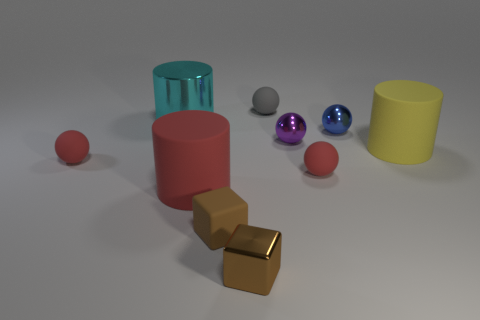Are there any tiny things of the same color as the small metallic cube?
Your answer should be compact. Yes. There is another block that is the same size as the brown metal cube; what color is it?
Offer a very short reply. Brown. Are the tiny brown cube to the right of the small matte cube and the tiny purple object made of the same material?
Provide a succinct answer. Yes. There is a tiny metal thing right of the tiny red matte sphere to the right of the large cyan cylinder; are there any large cylinders to the right of it?
Your answer should be very brief. Yes. Is the shape of the metallic object that is in front of the small purple metallic thing the same as  the tiny brown rubber thing?
Your response must be concise. Yes. There is a tiny red matte thing that is to the left of the shiny object in front of the tiny purple object; what shape is it?
Your response must be concise. Sphere. What is the size of the red rubber ball that is to the left of the matte cylinder in front of the red rubber thing that is on the left side of the cyan thing?
Offer a terse response. Small. There is another rubber thing that is the same shape as the large red matte object; what color is it?
Offer a very short reply. Yellow. Is the size of the red rubber cylinder the same as the matte block?
Your response must be concise. No. What material is the big thing that is to the right of the large red thing?
Your answer should be compact. Rubber. 